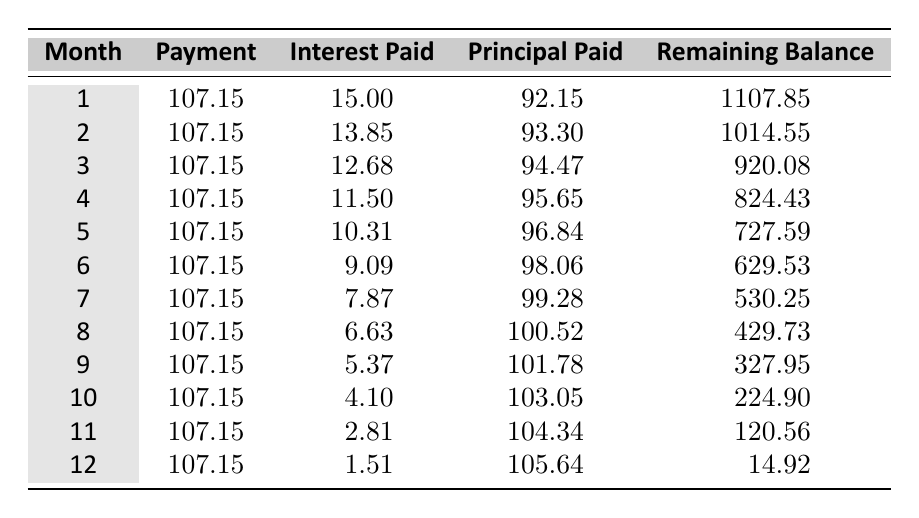What is the monthly payment throughout the amortization period? The table shows that the monthly payment remains constant at 107.15 for each of the 12 months of the amortization plan.
Answer: 107.15 How much interest was paid in month 4? Looking at the row for month 4 in the table, the interest paid is listed as 11.50.
Answer: 11.50 What is the total amount of principal paid over the entire year? To find the total principal paid, we add the principal paid for each month: 92.15 + 93.30 + 94.47 + 95.65 + 96.84 + 98.06 + 99.28 + 100.52 + 101.78 + 103.05 + 104.34 + 105.64 = 1174.94.
Answer: 1174.94 In which month was the interest payment the lowest? Scanning through the interest paid for each month, we see that the lowest interest payment occurs in month 12, which is 1.51.
Answer: Month 12 True or False: The remaining balance after month 6 is greater than 600. Checking the remaining balance after month 6, we find it is 629.53. Since 629.53 is greater than 600, the statement is true.
Answer: True How does the interest paid change from month 1 to month 12? The interest paid decreases from 15.00 in month 1 to 1.51 in month 12. This shows a steady decrease in interest paid each month.
Answer: Decreases What is the difference between the principal paid in month 5 and month 11? The principal paid in month 5 is 96.84 and in month 11 is 104.34. The difference is 104.34 - 96.84 = 7.50.
Answer: 7.50 What was the remaining balance at the end of month 9? Referring to the table, the remaining balance after month 9 is 327.95, clearly stated in the corresponding column for that month.
Answer: 327.95 What was the total payment made over the first six months? To find the total payment for the first six months, we multiply the monthly payment of 107.15 by 6: 107.15 x 6 = 643.90.
Answer: 643.90 